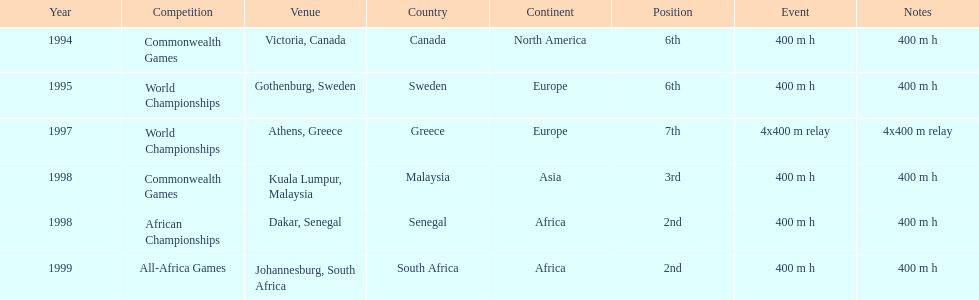In what year did ken harnden participate in more than one competition? 1998. Could you parse the entire table as a dict? {'header': ['Year', 'Competition', 'Venue', 'Country', 'Continent', 'Position', 'Event', 'Notes'], 'rows': [['1994', 'Commonwealth Games', 'Victoria, Canada', 'Canada', 'North America', '6th', '400 m h', '400 m h'], ['1995', 'World Championships', 'Gothenburg, Sweden', 'Sweden', 'Europe', '6th', '400 m h', '400 m h'], ['1997', 'World Championships', 'Athens, Greece', 'Greece', 'Europe', '7th', '4x400 m relay', '4x400 m relay'], ['1998', 'Commonwealth Games', 'Kuala Lumpur, Malaysia', 'Malaysia', 'Asia', '3rd', '400 m h', '400 m h'], ['1998', 'African Championships', 'Dakar, Senegal', 'Senegal', 'Africa', '2nd', '400 m h', '400 m h'], ['1999', 'All-Africa Games', 'Johannesburg, South Africa', 'South Africa', 'Africa', '2nd', '400 m h', '400 m h']]} 